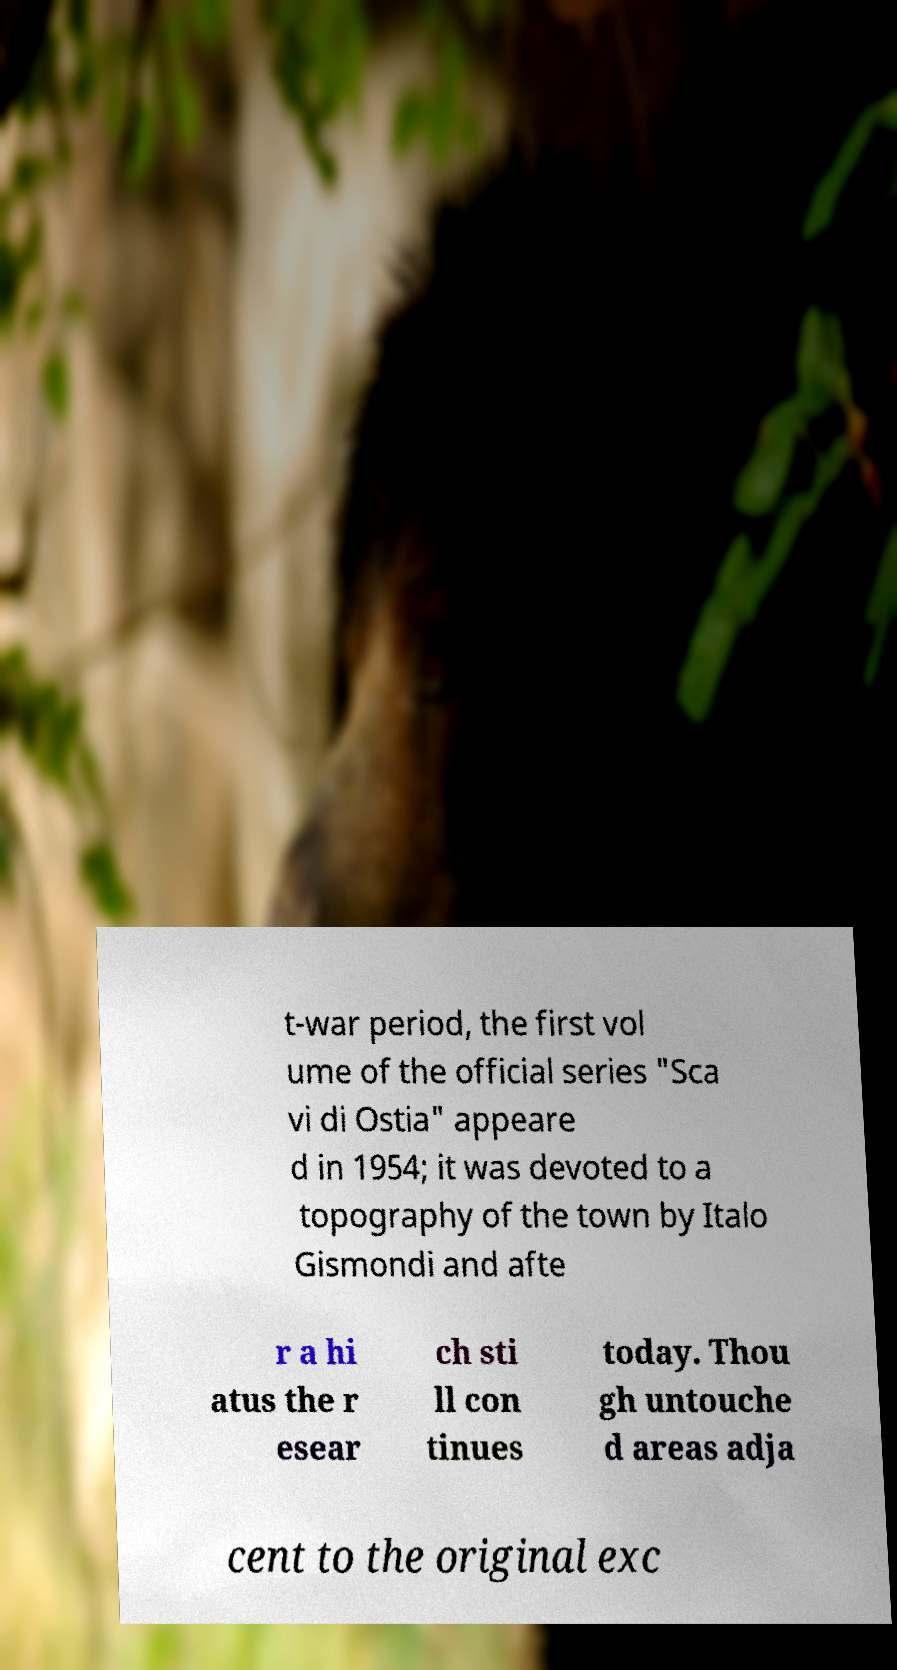Please identify and transcribe the text found in this image. t-war period, the first vol ume of the official series "Sca vi di Ostia" appeare d in 1954; it was devoted to a topography of the town by Italo Gismondi and afte r a hi atus the r esear ch sti ll con tinues today. Thou gh untouche d areas adja cent to the original exc 